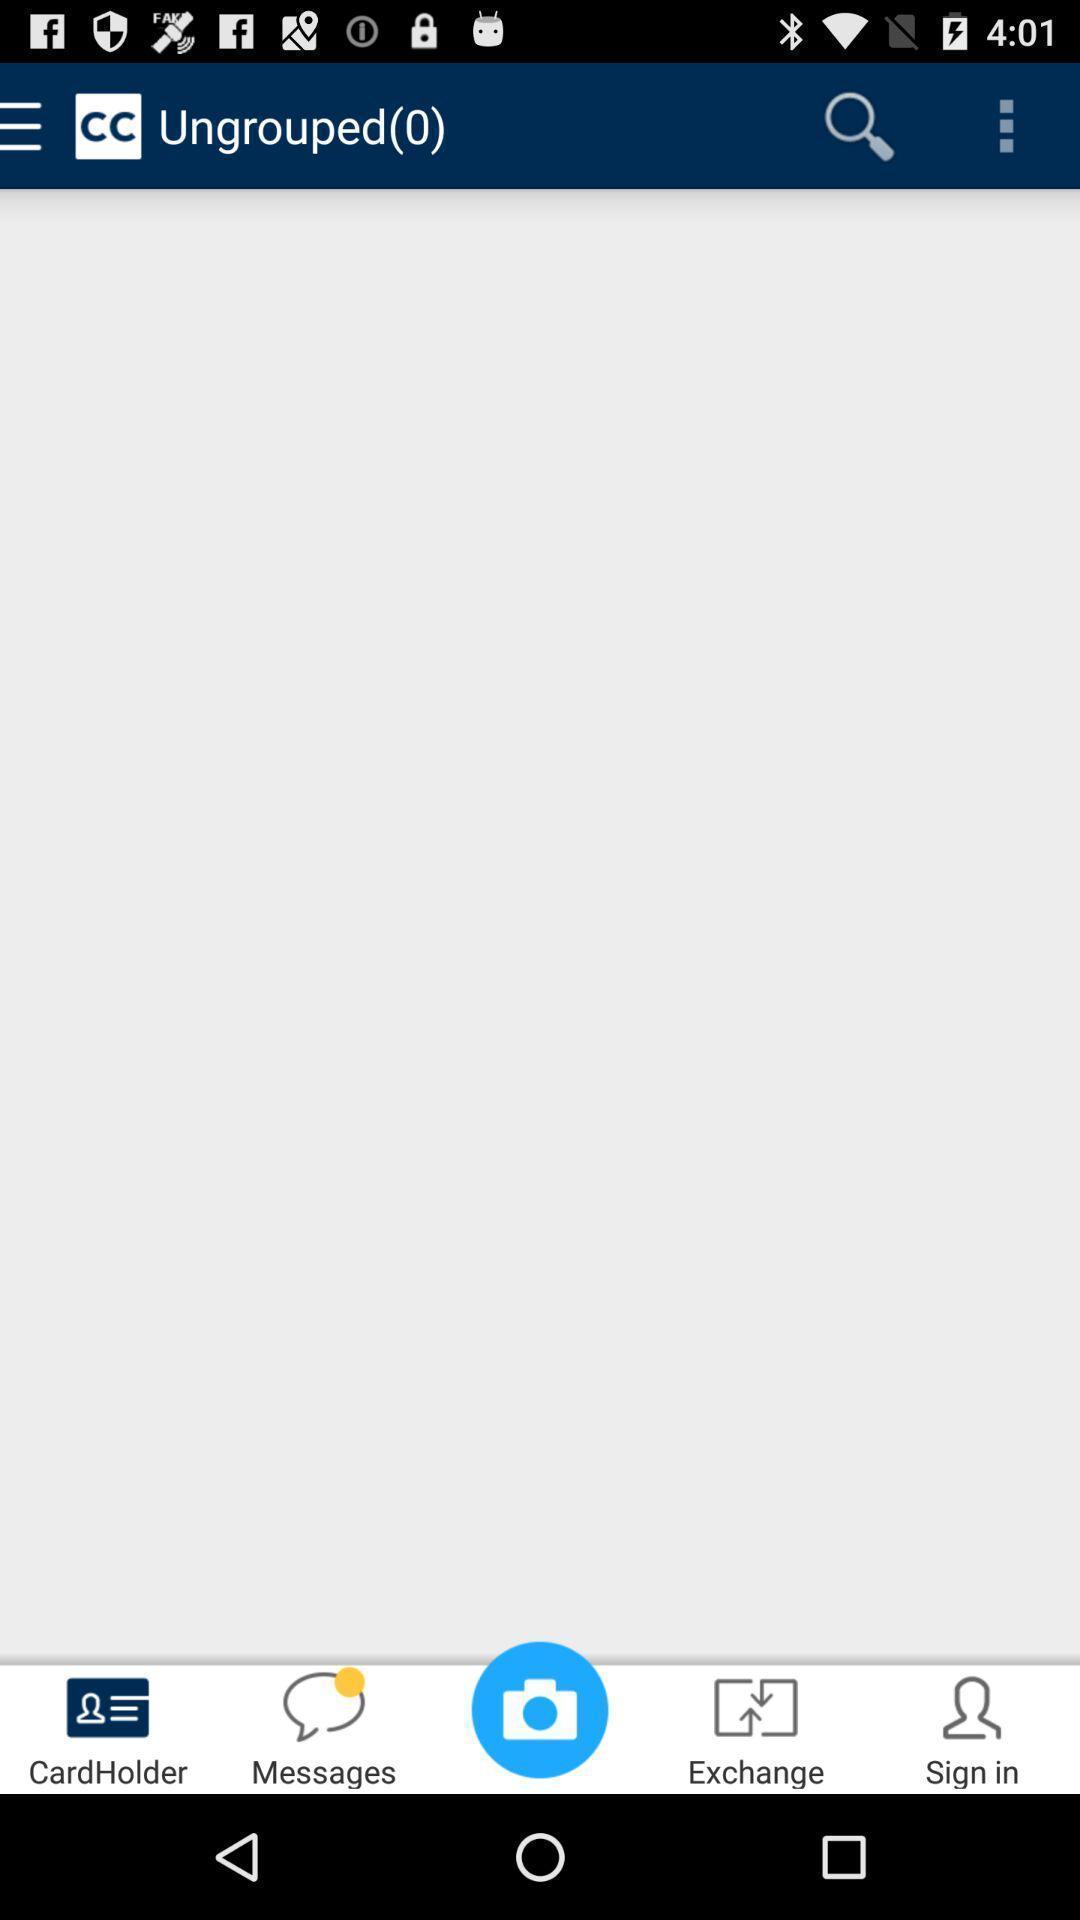Provide a description of this screenshot. Page displaying empty with many options for different groups. 